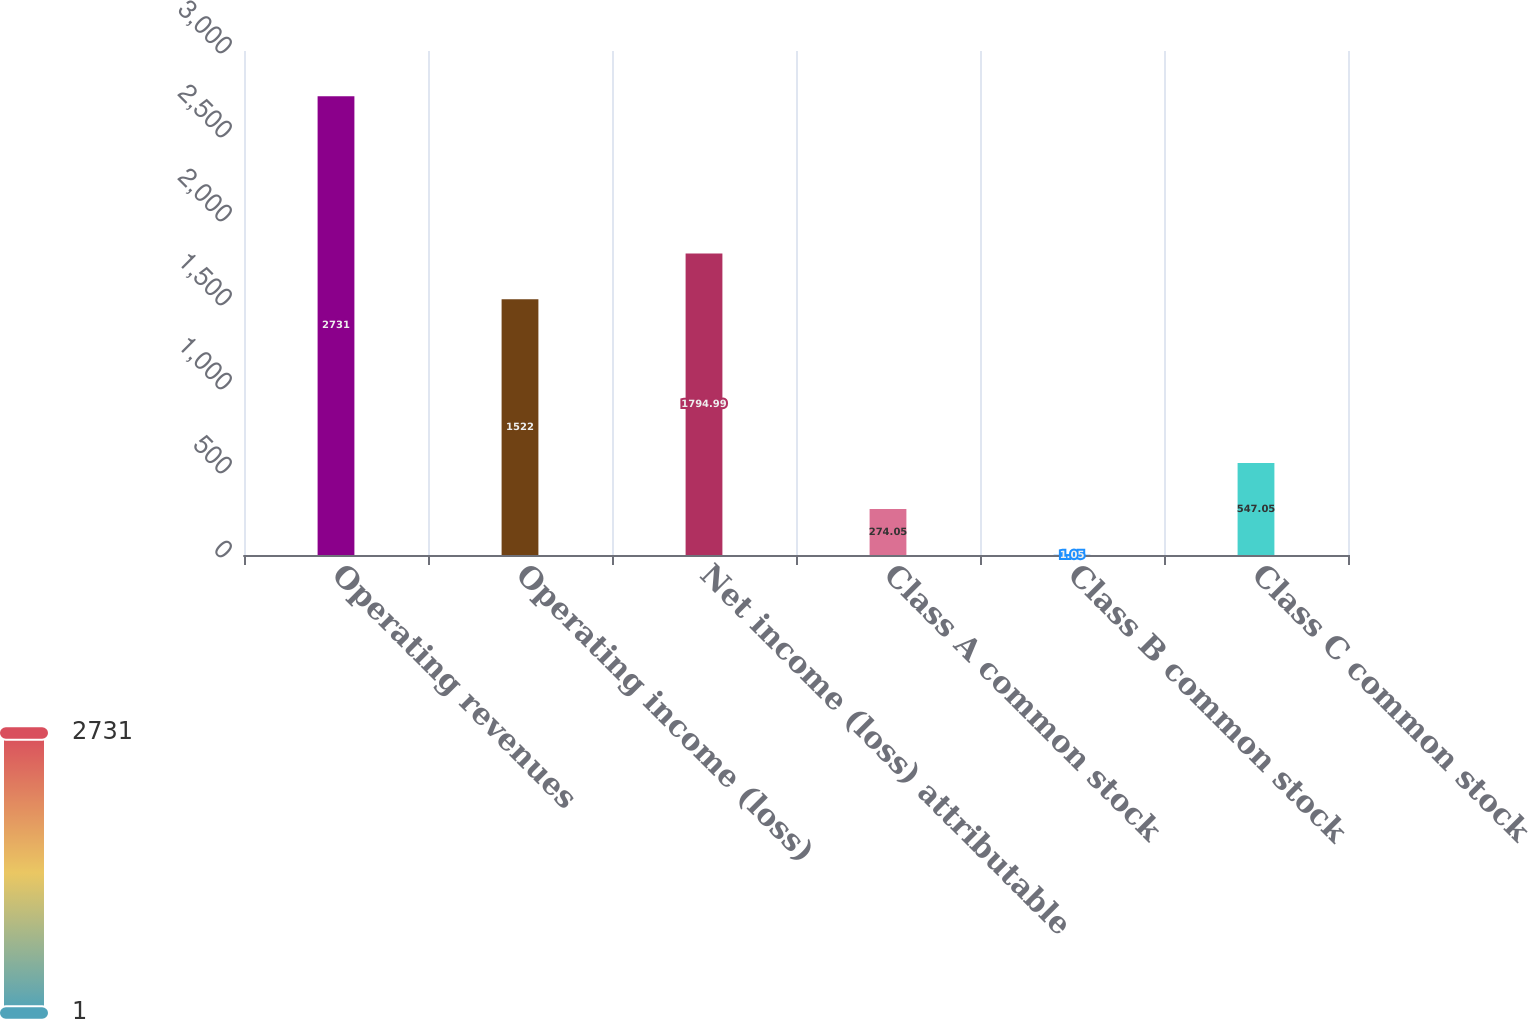<chart> <loc_0><loc_0><loc_500><loc_500><bar_chart><fcel>Operating revenues<fcel>Operating income (loss)<fcel>Net income (loss) attributable<fcel>Class A common stock<fcel>Class B common stock<fcel>Class C common stock<nl><fcel>2731<fcel>1522<fcel>1794.99<fcel>274.05<fcel>1.05<fcel>547.05<nl></chart> 